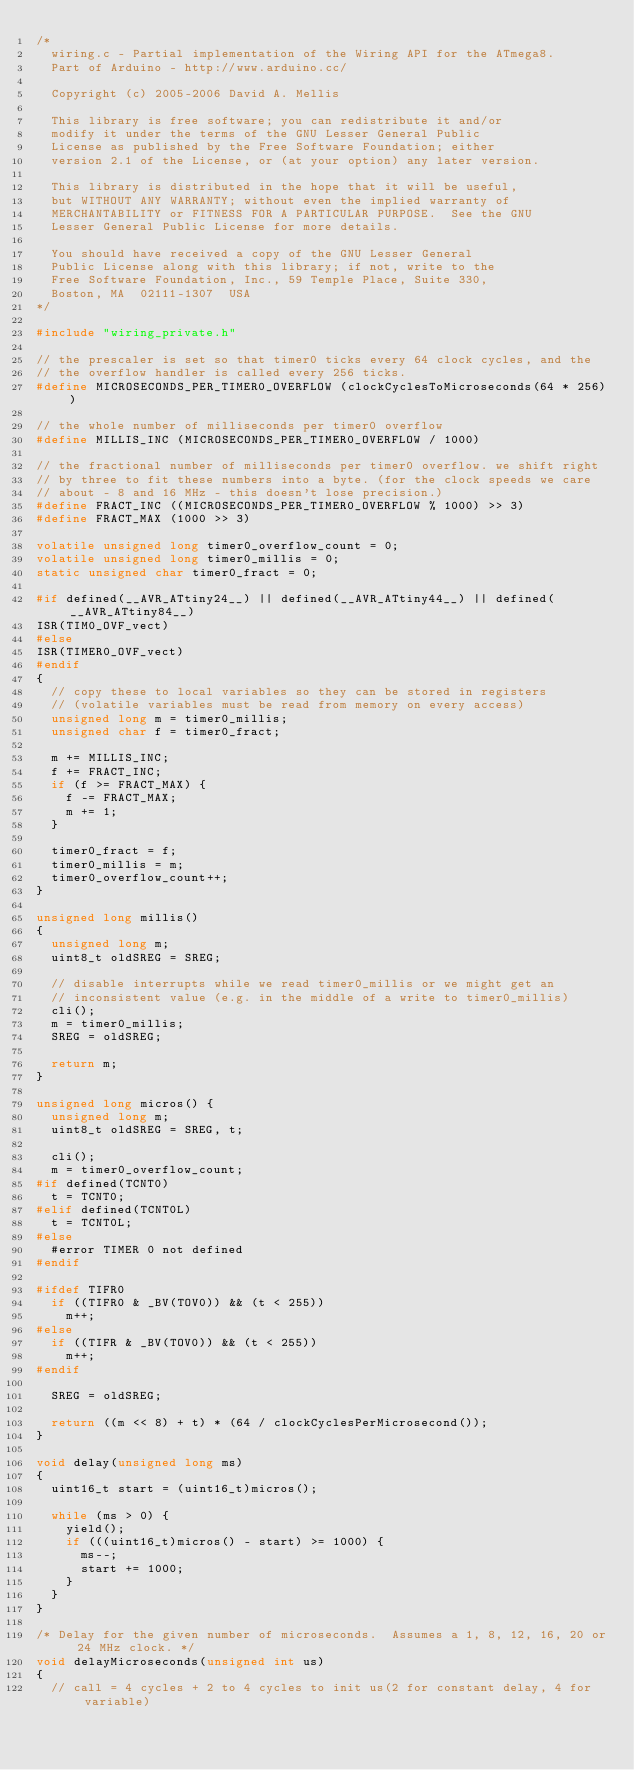<code> <loc_0><loc_0><loc_500><loc_500><_C_>/*
  wiring.c - Partial implementation of the Wiring API for the ATmega8.
  Part of Arduino - http://www.arduino.cc/

  Copyright (c) 2005-2006 David A. Mellis

  This library is free software; you can redistribute it and/or
  modify it under the terms of the GNU Lesser General Public
  License as published by the Free Software Foundation; either
  version 2.1 of the License, or (at your option) any later version.

  This library is distributed in the hope that it will be useful,
  but WITHOUT ANY WARRANTY; without even the implied warranty of
  MERCHANTABILITY or FITNESS FOR A PARTICULAR PURPOSE.  See the GNU
  Lesser General Public License for more details.

  You should have received a copy of the GNU Lesser General
  Public License along with this library; if not, write to the
  Free Software Foundation, Inc., 59 Temple Place, Suite 330,
  Boston, MA  02111-1307  USA
*/

#include "wiring_private.h"

// the prescaler is set so that timer0 ticks every 64 clock cycles, and the
// the overflow handler is called every 256 ticks.
#define MICROSECONDS_PER_TIMER0_OVERFLOW (clockCyclesToMicroseconds(64 * 256))

// the whole number of milliseconds per timer0 overflow
#define MILLIS_INC (MICROSECONDS_PER_TIMER0_OVERFLOW / 1000)

// the fractional number of milliseconds per timer0 overflow. we shift right
// by three to fit these numbers into a byte. (for the clock speeds we care
// about - 8 and 16 MHz - this doesn't lose precision.)
#define FRACT_INC ((MICROSECONDS_PER_TIMER0_OVERFLOW % 1000) >> 3)
#define FRACT_MAX (1000 >> 3)

volatile unsigned long timer0_overflow_count = 0;
volatile unsigned long timer0_millis = 0;
static unsigned char timer0_fract = 0;

#if defined(__AVR_ATtiny24__) || defined(__AVR_ATtiny44__) || defined(__AVR_ATtiny84__)
ISR(TIM0_OVF_vect)
#else
ISR(TIMER0_OVF_vect)
#endif
{
	// copy these to local variables so they can be stored in registers
	// (volatile variables must be read from memory on every access)
	unsigned long m = timer0_millis;
	unsigned char f = timer0_fract;

	m += MILLIS_INC;
	f += FRACT_INC;
	if (f >= FRACT_MAX) {
		f -= FRACT_MAX;
		m += 1;
	}

	timer0_fract = f;
	timer0_millis = m;
	timer0_overflow_count++;
}

unsigned long millis()
{
	unsigned long m;
	uint8_t oldSREG = SREG;

	// disable interrupts while we read timer0_millis or we might get an
	// inconsistent value (e.g. in the middle of a write to timer0_millis)
	cli();
	m = timer0_millis;
	SREG = oldSREG;

	return m;
}

unsigned long micros() {
	unsigned long m;
	uint8_t oldSREG = SREG, t;
	
	cli();
	m = timer0_overflow_count;
#if defined(TCNT0)
	t = TCNT0;
#elif defined(TCNT0L)
	t = TCNT0L;
#else
	#error TIMER 0 not defined
#endif

#ifdef TIFR0
	if ((TIFR0 & _BV(TOV0)) && (t < 255))
		m++;
#else
	if ((TIFR & _BV(TOV0)) && (t < 255))
		m++;
#endif

	SREG = oldSREG;
	
	return ((m << 8) + t) * (64 / clockCyclesPerMicrosecond());
}

void delay(unsigned long ms)
{
	uint16_t start = (uint16_t)micros();

	while (ms > 0) {
		yield();
		if (((uint16_t)micros() - start) >= 1000) {
			ms--;
			start += 1000;
		}
	}
}

/* Delay for the given number of microseconds.  Assumes a 1, 8, 12, 16, 20 or 24 MHz clock. */
void delayMicroseconds(unsigned int us)
{
	// call = 4 cycles + 2 to 4 cycles to init us(2 for constant delay, 4 for variable)
</code> 